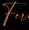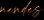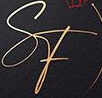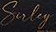What text appears in these images from left to right, separated by a semicolon? Fu; #####; SF; Suley 